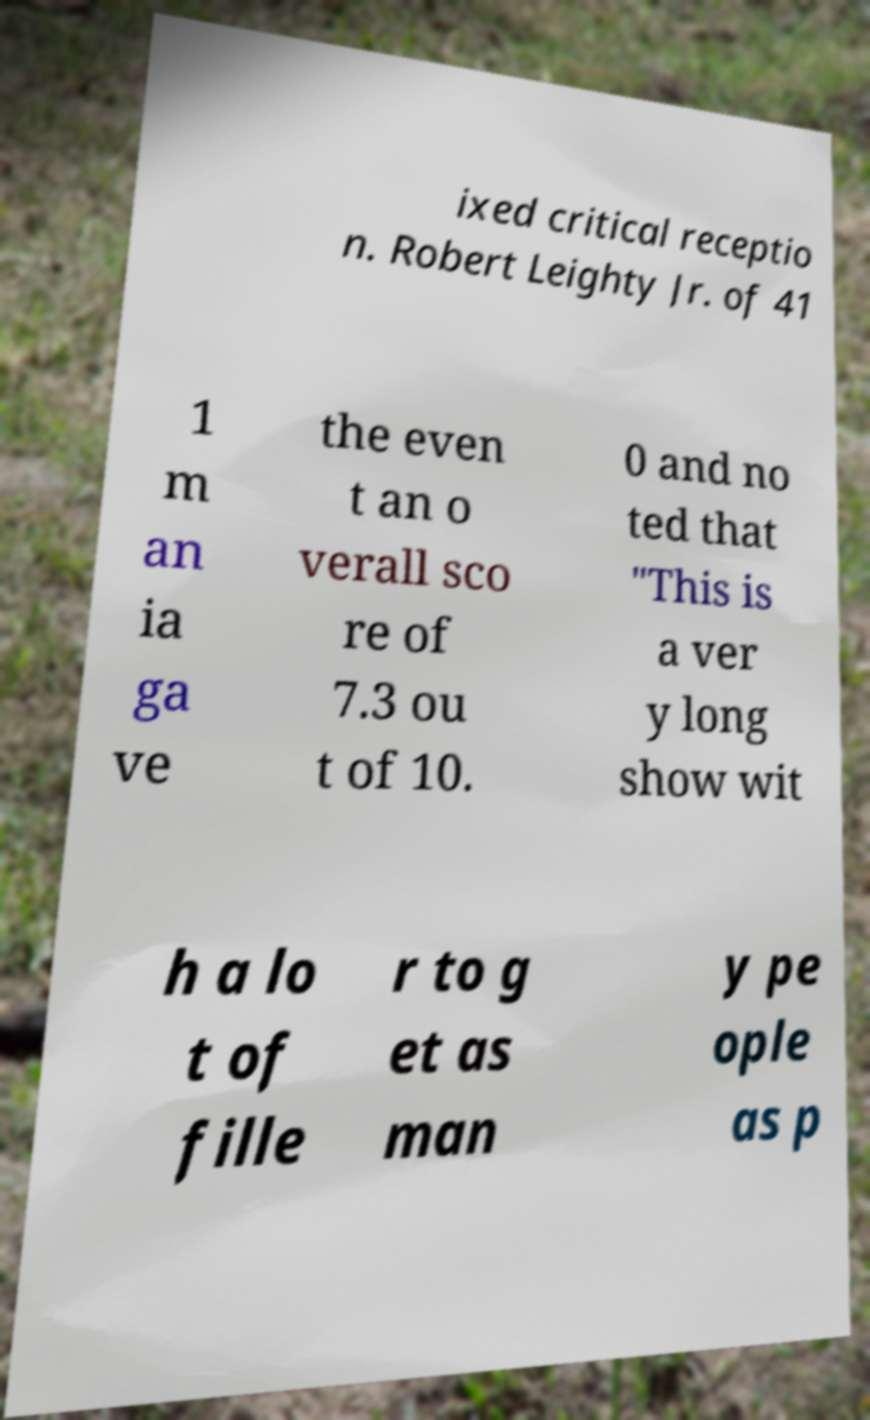Can you read and provide the text displayed in the image?This photo seems to have some interesting text. Can you extract and type it out for me? ixed critical receptio n. Robert Leighty Jr. of 41 1 m an ia ga ve the even t an o verall sco re of 7.3 ou t of 10. 0 and no ted that "This is a ver y long show wit h a lo t of fille r to g et as man y pe ople as p 